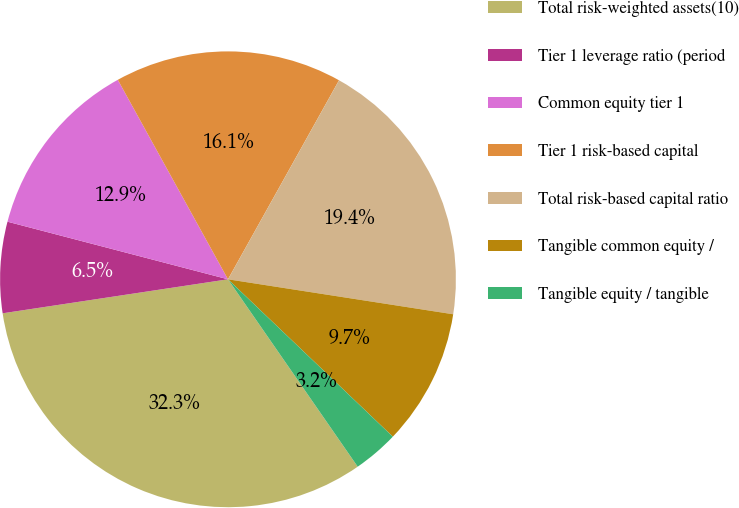<chart> <loc_0><loc_0><loc_500><loc_500><pie_chart><fcel>Total risk-weighted assets(10)<fcel>Tier 1 leverage ratio (period<fcel>Common equity tier 1<fcel>Tier 1 risk-based capital<fcel>Total risk-based capital ratio<fcel>Tangible common equity /<fcel>Tangible equity / tangible<nl><fcel>32.25%<fcel>6.45%<fcel>12.9%<fcel>16.13%<fcel>19.35%<fcel>9.68%<fcel>3.23%<nl></chart> 